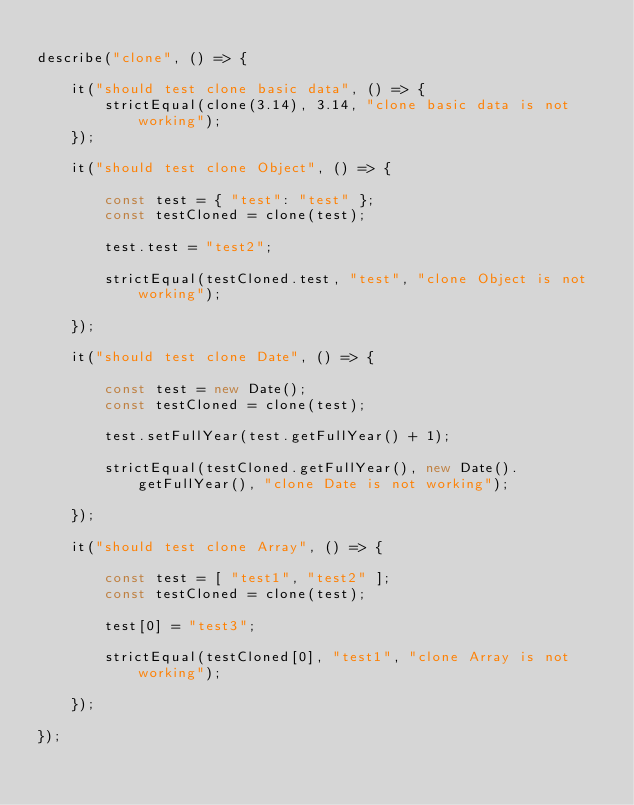Convert code to text. <code><loc_0><loc_0><loc_500><loc_500><_JavaScript_>
describe("clone", () => {

	it("should test clone basic data", () => {
		strictEqual(clone(3.14), 3.14, "clone basic data is not working");
	});

	it("should test clone Object", () => {

		const test = { "test": "test" };
		const testCloned = clone(test);

		test.test = "test2";

		strictEqual(testCloned.test, "test", "clone Object is not working");

	});

	it("should test clone Date", () => {

		const test = new Date();
		const testCloned = clone(test);

		test.setFullYear(test.getFullYear() + 1);

		strictEqual(testCloned.getFullYear(), new Date().getFullYear(), "clone Date is not working");

	});

	it("should test clone Array", () => {

		const test = [ "test1", "test2" ];
		const testCloned = clone(test);

		test[0] = "test3";

		strictEqual(testCloned[0], "test1", "clone Array is not working");

	});

});
</code> 